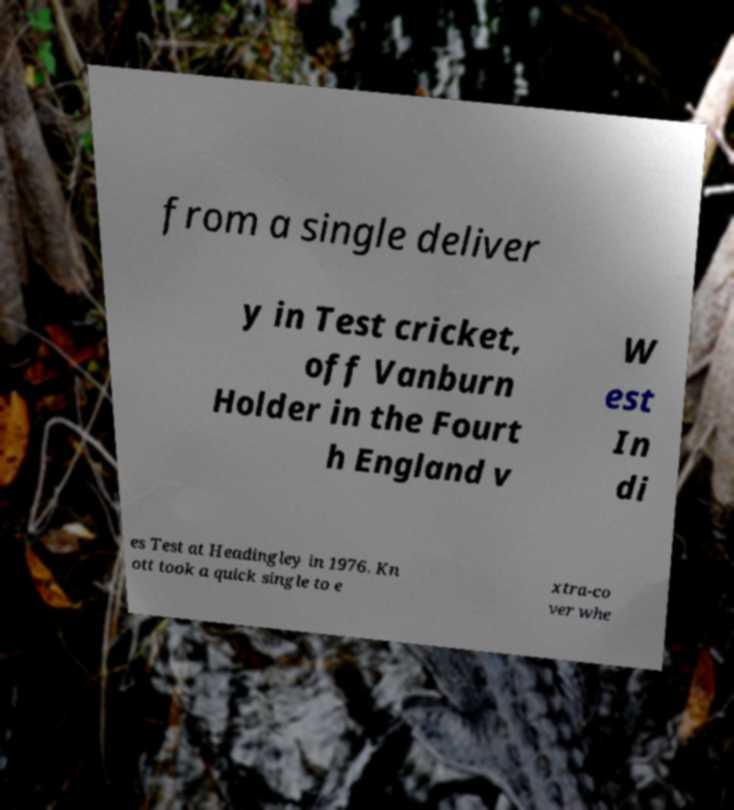Please read and relay the text visible in this image. What does it say? from a single deliver y in Test cricket, off Vanburn Holder in the Fourt h England v W est In di es Test at Headingley in 1976. Kn ott took a quick single to e xtra-co ver whe 